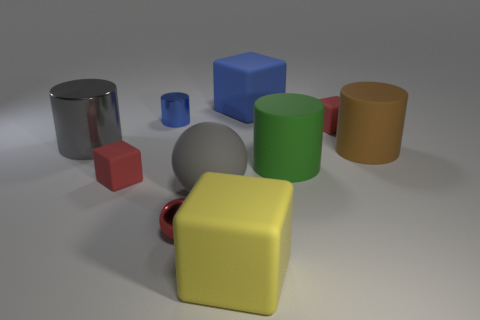What material is the thing that is the same color as the tiny shiny cylinder? The small object that shares its color with the tiny shiny cylinder appears to be made of plastic. 